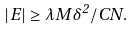Convert formula to latex. <formula><loc_0><loc_0><loc_500><loc_500>| E | \geq \lambda M \delta ^ { 2 } / C N .</formula> 